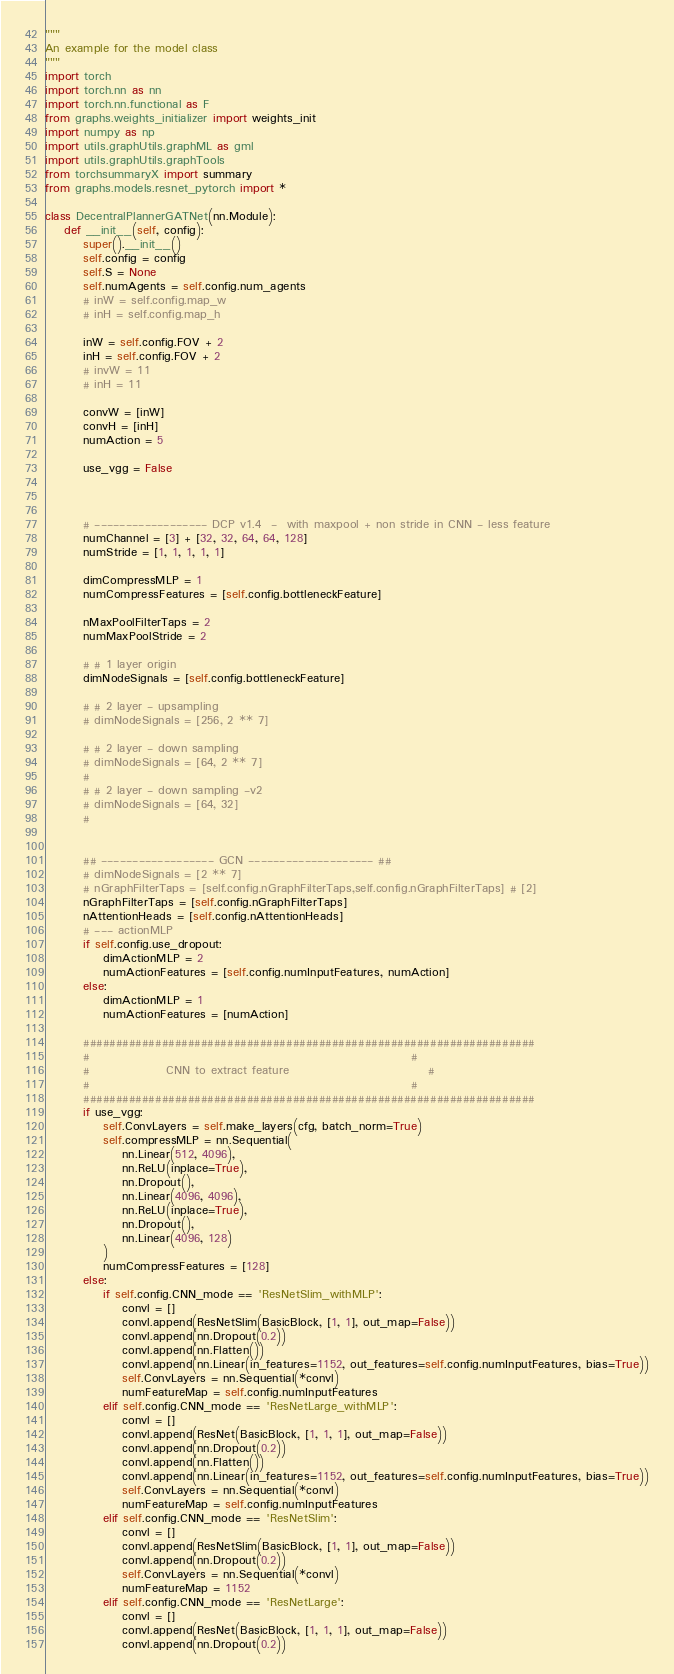Convert code to text. <code><loc_0><loc_0><loc_500><loc_500><_Python_>"""
An example for the model class
"""
import torch
import torch.nn as nn
import torch.nn.functional as F
from graphs.weights_initializer import weights_init
import numpy as np
import utils.graphUtils.graphML as gml
import utils.graphUtils.graphTools
from torchsummaryX import summary
from graphs.models.resnet_pytorch import *

class DecentralPlannerGATNet(nn.Module):
    def __init__(self, config):
        super().__init__()
        self.config = config
        self.S = None
        self.numAgents = self.config.num_agents
        # inW = self.config.map_w
        # inH = self.config.map_h

        inW = self.config.FOV + 2
        inH = self.config.FOV + 2
        # invW = 11
        # inH = 11

        convW = [inW]
        convH = [inH]
        numAction = 5

        use_vgg = False



        # ------------------ DCP v1.4  -  with maxpool + non stride in CNN - less feature
        numChannel = [3] + [32, 32, 64, 64, 128]
        numStride = [1, 1, 1, 1, 1]

        dimCompressMLP = 1
        numCompressFeatures = [self.config.bottleneckFeature]

        nMaxPoolFilterTaps = 2
        numMaxPoolStride = 2

        # # 1 layer origin
        dimNodeSignals = [self.config.bottleneckFeature]

        # # 2 layer - upsampling
        # dimNodeSignals = [256, 2 ** 7]

        # # 2 layer - down sampling
        # dimNodeSignals = [64, 2 ** 7]
        #
        # # 2 layer - down sampling -v2
        # dimNodeSignals = [64, 32]
        #


        ## ------------------ GCN -------------------- ##
        # dimNodeSignals = [2 ** 7]
        # nGraphFilterTaps = [self.config.nGraphFilterTaps,self.config.nGraphFilterTaps] # [2]
        nGraphFilterTaps = [self.config.nGraphFilterTaps]
        nAttentionHeads = [self.config.nAttentionHeads]
        # --- actionMLP
        if self.config.use_dropout:
            dimActionMLP = 2
            numActionFeatures = [self.config.numInputFeatures, numAction]
        else:
            dimActionMLP = 1
            numActionFeatures = [numAction]

        #####################################################################
        #                                                                   #
        #                CNN to extract feature                             #
        #                                                                   #
        #####################################################################
        if use_vgg:
            self.ConvLayers = self.make_layers(cfg, batch_norm=True)
            self.compressMLP = nn.Sequential(
                nn.Linear(512, 4096),
                nn.ReLU(inplace=True),
                nn.Dropout(),
                nn.Linear(4096, 4096),
                nn.ReLU(inplace=True),
                nn.Dropout(),
                nn.Linear(4096, 128)
            )
            numCompressFeatures = [128]
        else:
            if self.config.CNN_mode == 'ResNetSlim_withMLP':
                convl = []
                convl.append(ResNetSlim(BasicBlock, [1, 1], out_map=False))
                convl.append(nn.Dropout(0.2))
                convl.append(nn.Flatten())
                convl.append(nn.Linear(in_features=1152, out_features=self.config.numInputFeatures, bias=True))
                self.ConvLayers = nn.Sequential(*convl)
                numFeatureMap = self.config.numInputFeatures
            elif self.config.CNN_mode == 'ResNetLarge_withMLP':
                convl = []
                convl.append(ResNet(BasicBlock, [1, 1, 1], out_map=False))
                convl.append(nn.Dropout(0.2))
                convl.append(nn.Flatten())
                convl.append(nn.Linear(in_features=1152, out_features=self.config.numInputFeatures, bias=True))
                self.ConvLayers = nn.Sequential(*convl)
                numFeatureMap = self.config.numInputFeatures
            elif self.config.CNN_mode == 'ResNetSlim':
                convl = []
                convl.append(ResNetSlim(BasicBlock, [1, 1], out_map=False))
                convl.append(nn.Dropout(0.2))
                self.ConvLayers = nn.Sequential(*convl)
                numFeatureMap = 1152
            elif self.config.CNN_mode == 'ResNetLarge':
                convl = []
                convl.append(ResNet(BasicBlock, [1, 1, 1], out_map=False))
                convl.append(nn.Dropout(0.2))</code> 